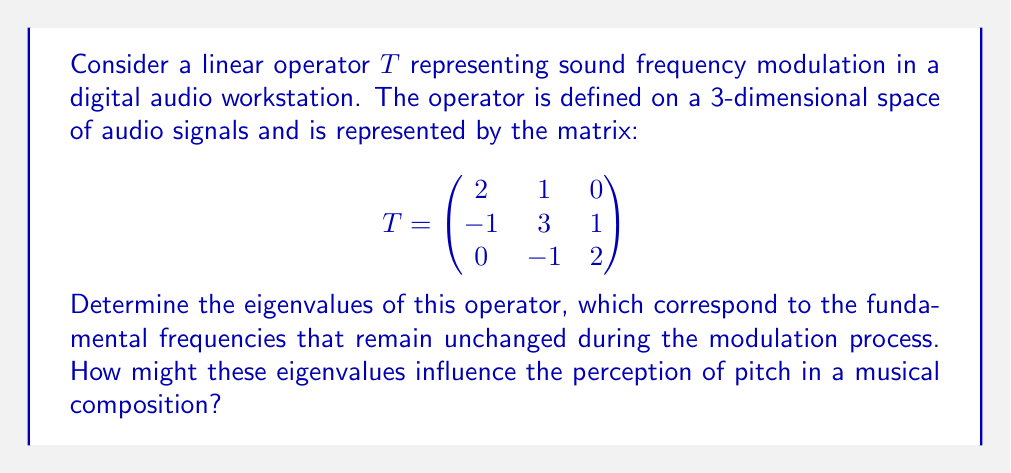Can you solve this math problem? To find the eigenvalues of the linear operator $T$, we need to solve the characteristic equation:

$$\det(T - \lambda I) = 0$$

Where $I$ is the 3x3 identity matrix and $\lambda$ represents the eigenvalues.

Step 1: Set up the characteristic equation:

$$
\det\begin{pmatrix}
2-\lambda & 1 & 0 \\
-1 & 3-\lambda & 1 \\
0 & -1 & 2-\lambda
\end{pmatrix} = 0
$$

Step 2: Expand the determinant:

$$(2-\lambda)[(3-\lambda)(2-\lambda) - (-1)(1)] - 1[(-1)(2-\lambda) - 0] + 0 = 0$$

Step 3: Simplify:

$$(2-\lambda)[(3-\lambda)(2-\lambda) + 1] + (2-\lambda) = 0$$
$$(2-\lambda)[(3-\lambda)(2-\lambda) + 2] = 0$$

Step 4: Expand further:

$$(2-\lambda)[6-5\lambda+\lambda^2 + 2] = 0$$
$$(2-\lambda)[\lambda^2 - 5\lambda + 8] = 0$$

Step 5: Factor the equation:

$$(2-\lambda)(\lambda-2)(\lambda-3) = 0$$

Step 6: Solve for $\lambda$:

The eigenvalues are the solutions to this equation:
$\lambda = 2$ (with multiplicity 2) and $\lambda = 3$

Interpretation for a musician:
The eigenvalues 2 and 3 represent frequencies that remain unchanged during the modulation process. In a musical context, these could be thought of as fundamental frequencies or harmonics that are preserved, while other frequencies are altered. 

The fact that 2 is an eigenvalue with multiplicity 2 suggests that this frequency (or its musical equivalent) has a stronger presence in the modulated sound. This could result in a more pronounced perception of the corresponding pitch.

The eigenvalue 3 represents another preserved frequency, which might be perceived as a secondary stable pitch in the modulated sound.

These stable frequencies could serve as anchor points in the composition, providing a sense of tonal stability amidst the modulation effects. A skilled composer or sound designer could use this knowledge to create interesting harmonic relationships or to ensure certain pitches remain clear and identifiable even when applying complex modulation effects.
Answer: The eigenvalues of the linear operator $T$ are:
$$\lambda_1 = 2 \text{ (with multiplicity 2)}, \lambda_2 = 3$$ 